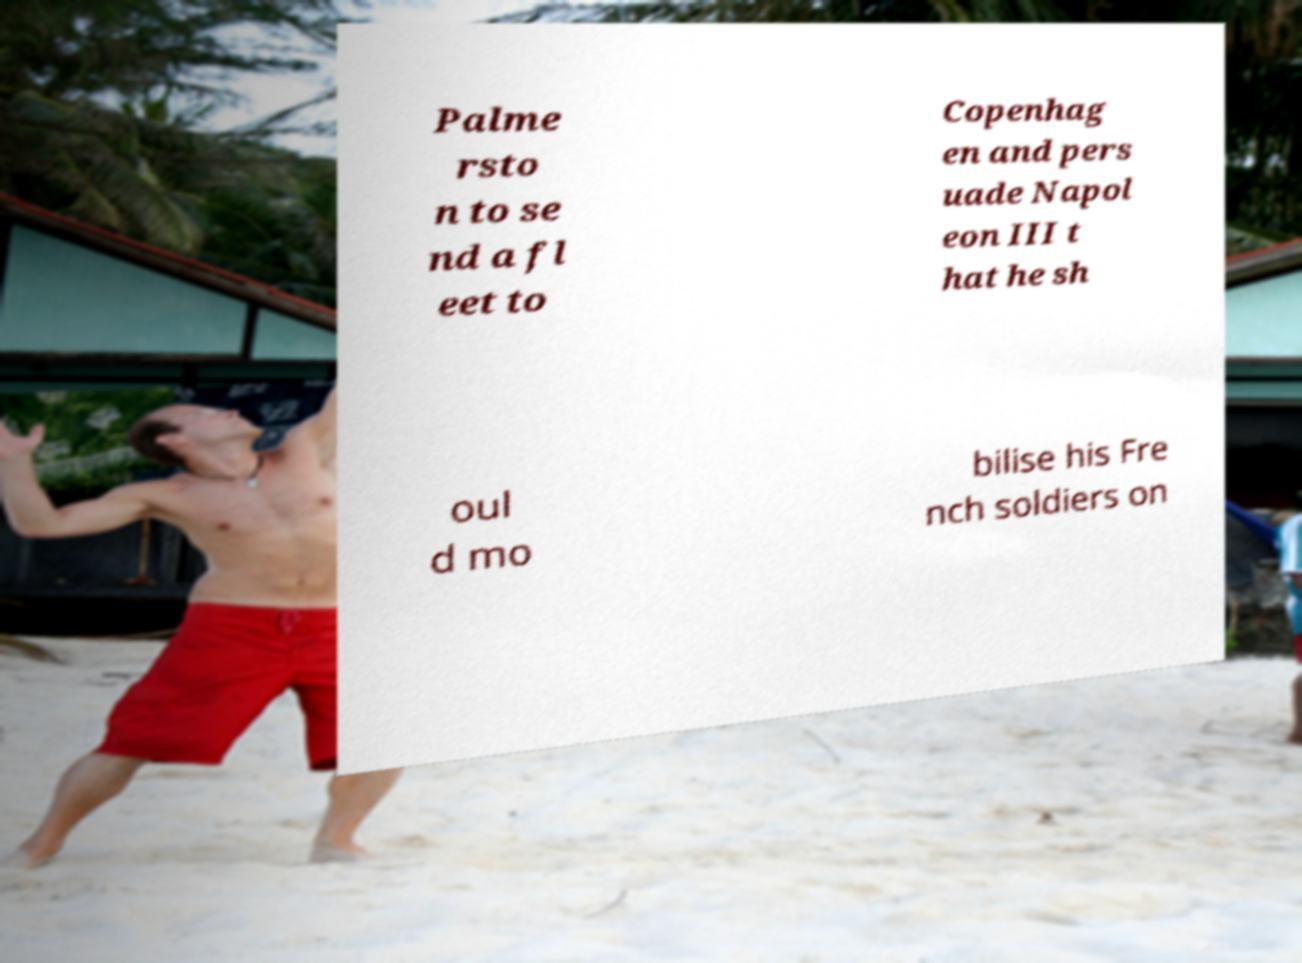What messages or text are displayed in this image? I need them in a readable, typed format. Palme rsto n to se nd a fl eet to Copenhag en and pers uade Napol eon III t hat he sh oul d mo bilise his Fre nch soldiers on 